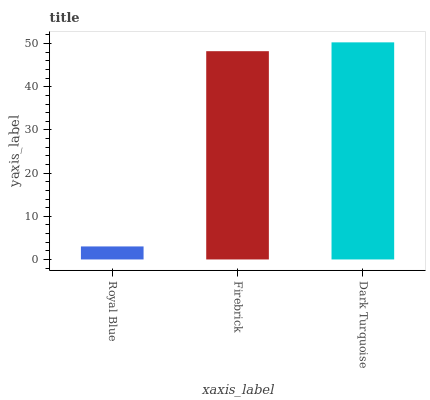Is Royal Blue the minimum?
Answer yes or no. Yes. Is Dark Turquoise the maximum?
Answer yes or no. Yes. Is Firebrick the minimum?
Answer yes or no. No. Is Firebrick the maximum?
Answer yes or no. No. Is Firebrick greater than Royal Blue?
Answer yes or no. Yes. Is Royal Blue less than Firebrick?
Answer yes or no. Yes. Is Royal Blue greater than Firebrick?
Answer yes or no. No. Is Firebrick less than Royal Blue?
Answer yes or no. No. Is Firebrick the high median?
Answer yes or no. Yes. Is Firebrick the low median?
Answer yes or no. Yes. Is Dark Turquoise the high median?
Answer yes or no. No. Is Dark Turquoise the low median?
Answer yes or no. No. 